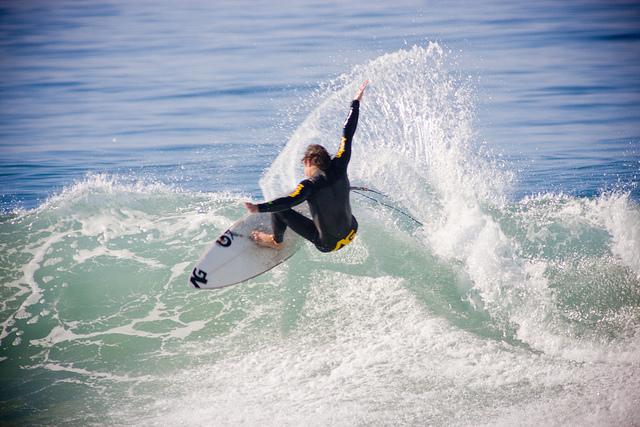Is this person's gender obvious?
Short answer required. No. Has this person surfed before?
Short answer required. Yes. What color is the surfboard?
Quick response, please. White. 